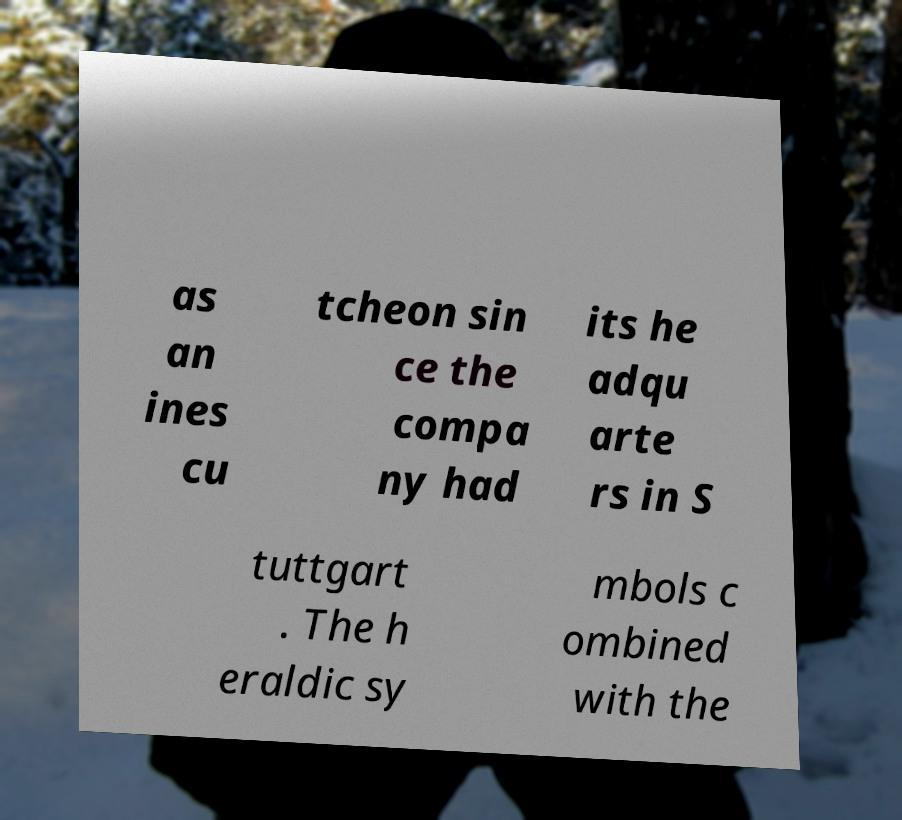What messages or text are displayed in this image? I need them in a readable, typed format. as an ines cu tcheon sin ce the compa ny had its he adqu arte rs in S tuttgart . The h eraldic sy mbols c ombined with the 